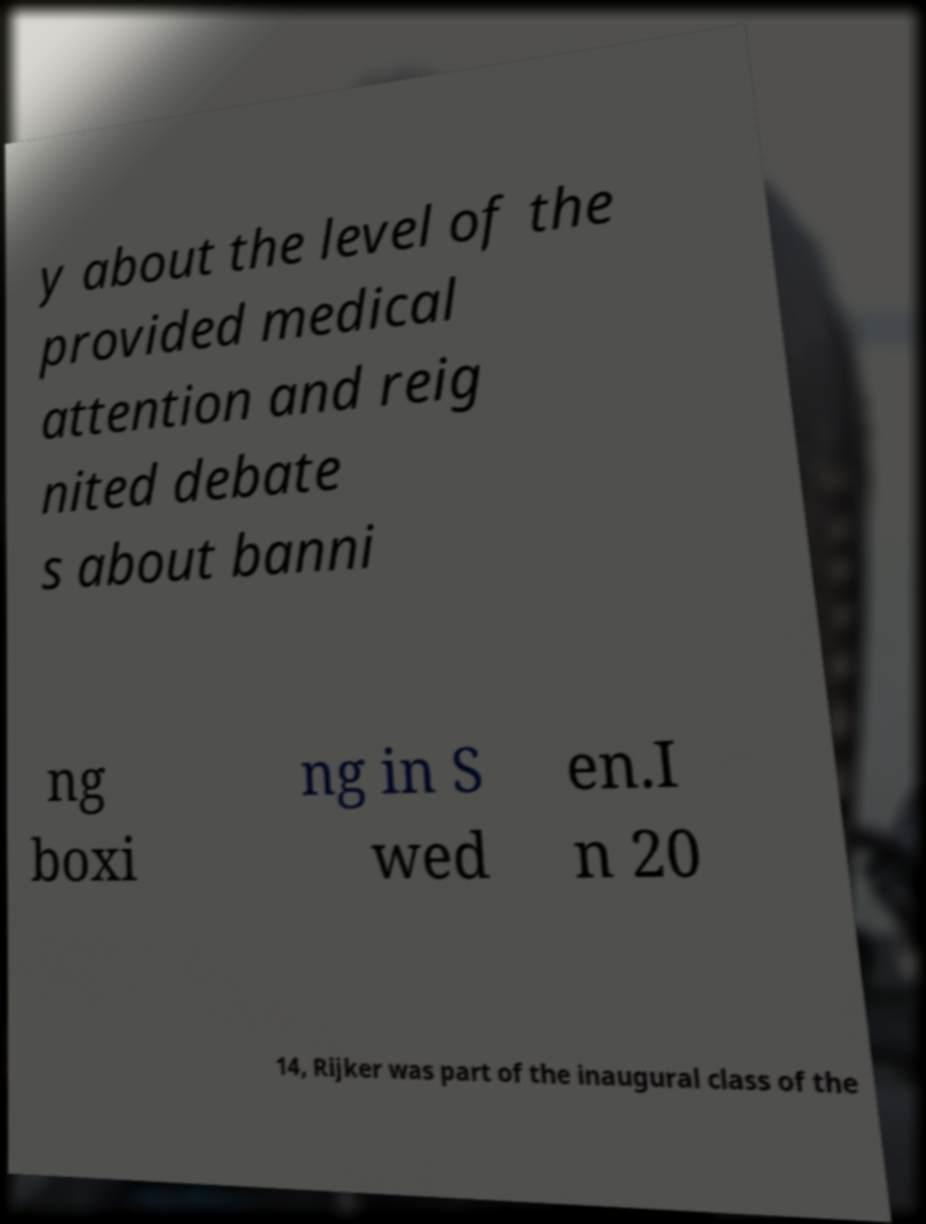I need the written content from this picture converted into text. Can you do that? y about the level of the provided medical attention and reig nited debate s about banni ng boxi ng in S wed en.I n 20 14, Rijker was part of the inaugural class of the 